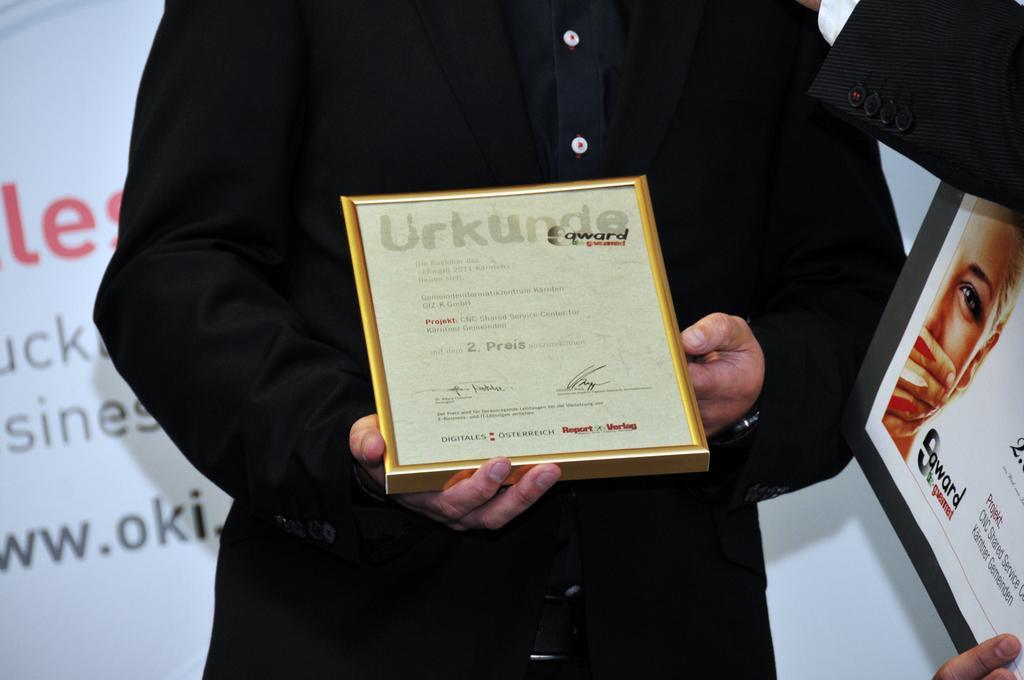In one or two sentences, can you explain what this image depicts? In this picture I can see a person standing and holding a certificate, there are fingers of a person on a board, and in the background there is a board. 